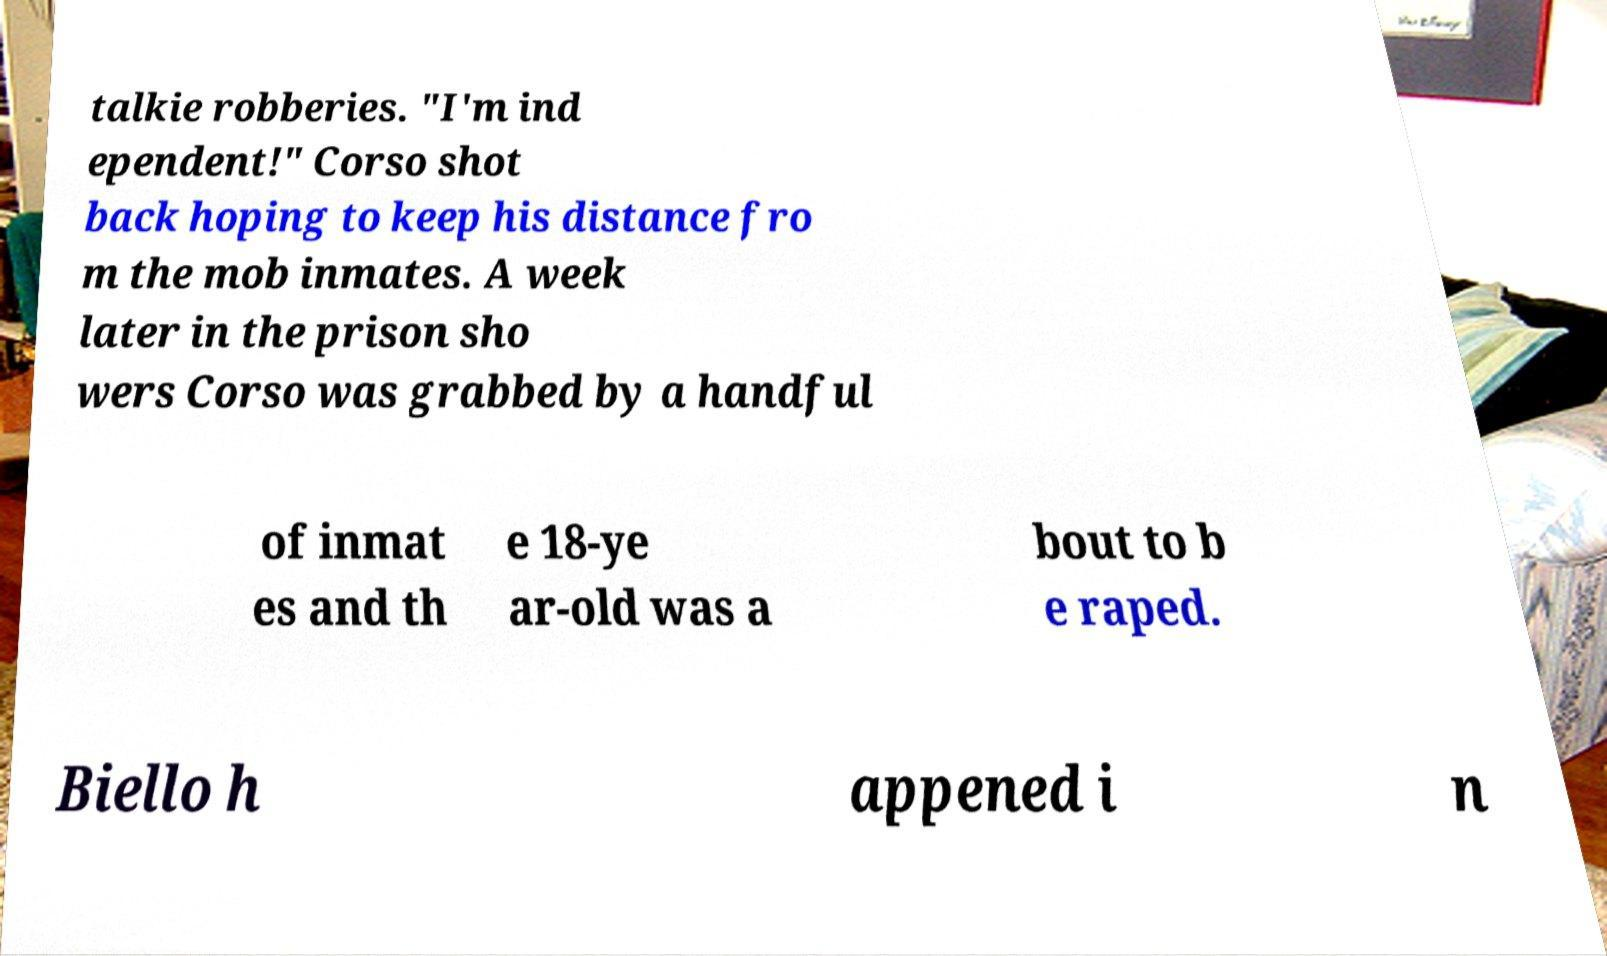For documentation purposes, I need the text within this image transcribed. Could you provide that? talkie robberies. "I'm ind ependent!" Corso shot back hoping to keep his distance fro m the mob inmates. A week later in the prison sho wers Corso was grabbed by a handful of inmat es and th e 18-ye ar-old was a bout to b e raped. Biello h appened i n 